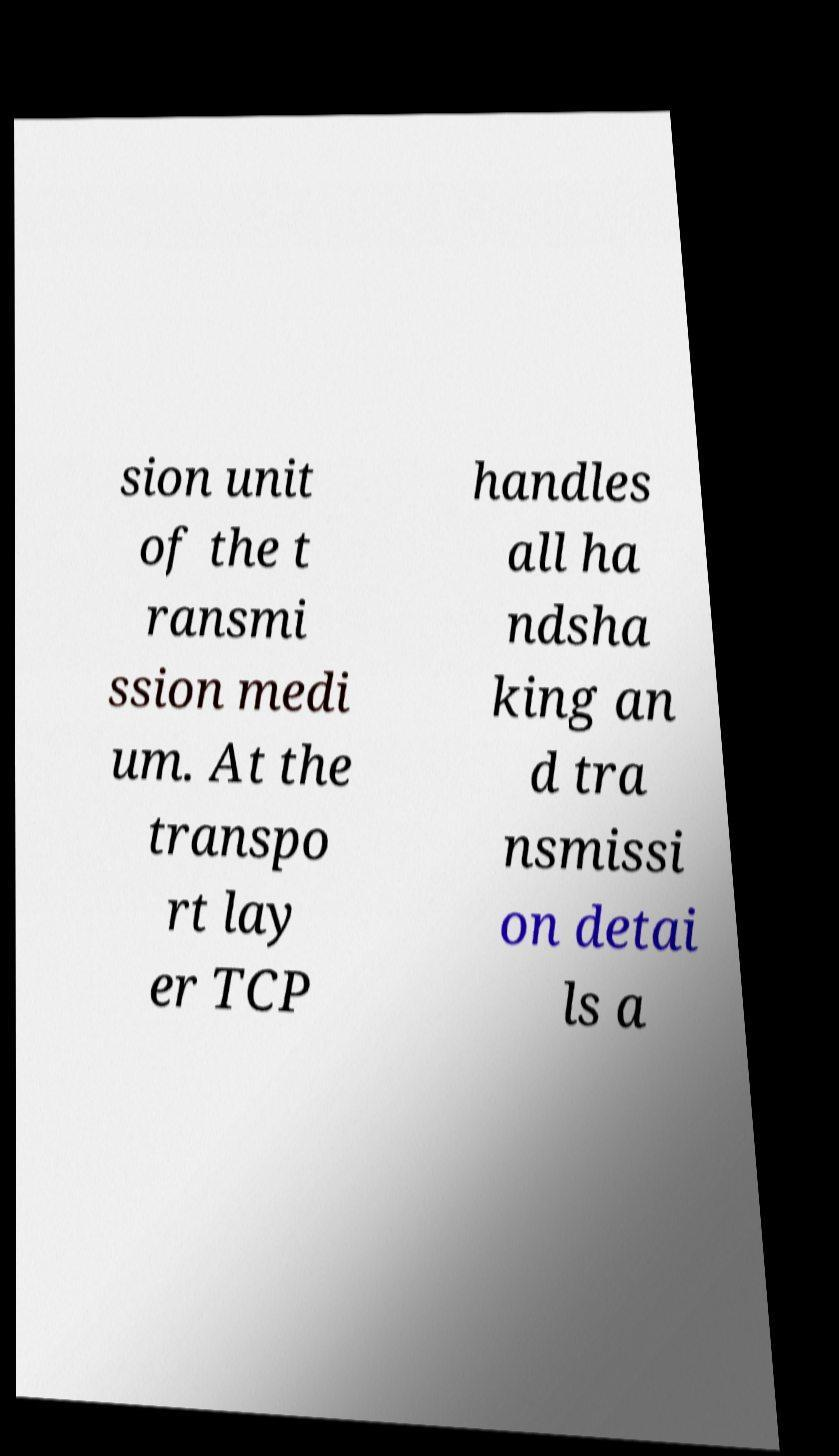Can you accurately transcribe the text from the provided image for me? sion unit of the t ransmi ssion medi um. At the transpo rt lay er TCP handles all ha ndsha king an d tra nsmissi on detai ls a 